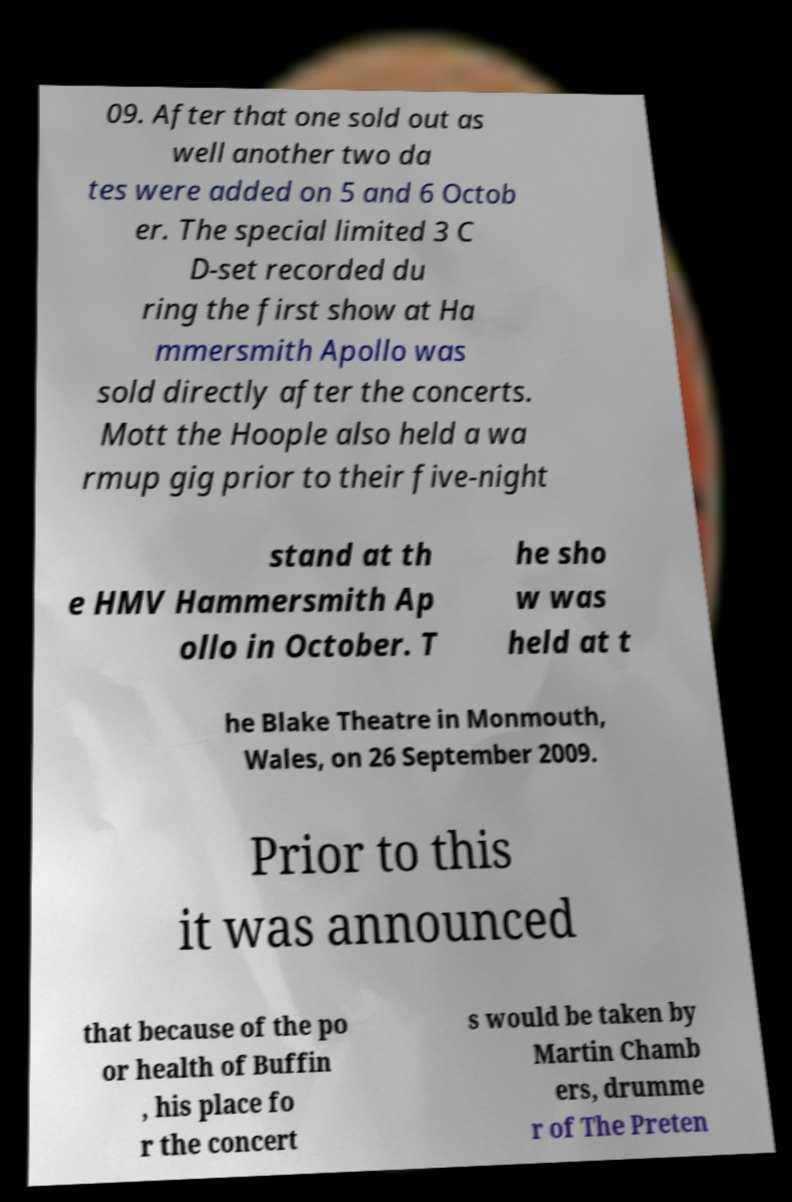Can you accurately transcribe the text from the provided image for me? 09. After that one sold out as well another two da tes were added on 5 and 6 Octob er. The special limited 3 C D-set recorded du ring the first show at Ha mmersmith Apollo was sold directly after the concerts. Mott the Hoople also held a wa rmup gig prior to their five-night stand at th e HMV Hammersmith Ap ollo in October. T he sho w was held at t he Blake Theatre in Monmouth, Wales, on 26 September 2009. Prior to this it was announced that because of the po or health of Buffin , his place fo r the concert s would be taken by Martin Chamb ers, drumme r of The Preten 